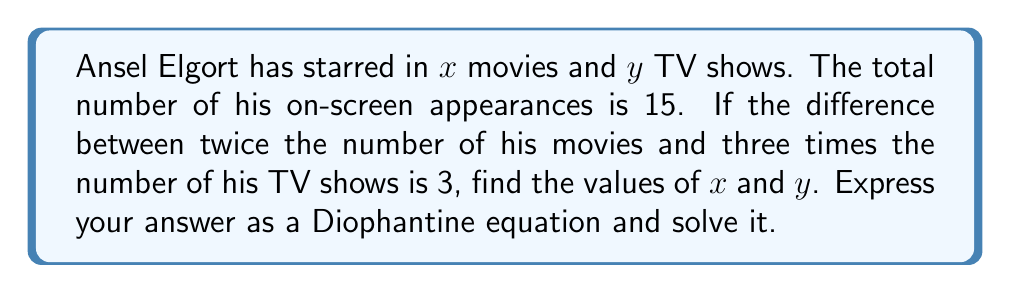Provide a solution to this math problem. Let's approach this step-by-step:

1) First, let's set up our equations based on the given information:

   $x + y = 15$ (total appearances)
   $2x - 3y = 3$ (difference equation)

2) This is a system of two Diophantine equations. We need to solve for positive integer values of $x$ and $y$.

3) From the first equation, we can express $y$ in terms of $x$:
   $y = 15 - x$

4) Substituting this into the second equation:
   $2x - 3(15 - x) = 3$

5) Simplify:
   $2x - 45 + 3x = 3$
   $5x - 45 = 3$
   $5x = 48$
   $x = \frac{48}{5}$

6) Since $x$ must be an integer, 48 must be divisible by 5. The only solution that satisfies this and keeps both $x$ and $y$ positive is:

   $x = 9$ and $y = 6$

7) We can verify:
   $9 + 6 = 15$ (checks out)
   $2(9) - 3(6) = 18 - 18 = 0$ (checks out, as 3 = 3)

Therefore, the solution to the Diophantine equation is $x = 9$ and $y = 6$.
Answer: $x = 9$, $y = 6$ 